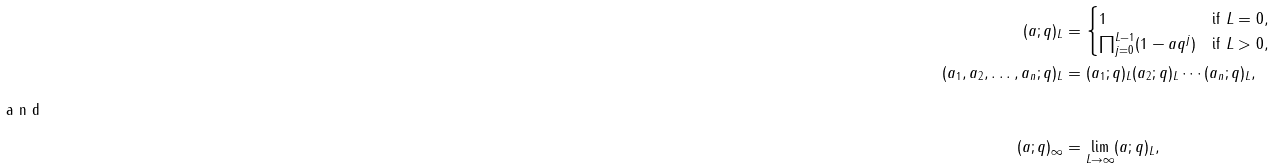<formula> <loc_0><loc_0><loc_500><loc_500>( a ; q ) _ { L } & = \begin{cases} 1 & \text {if } L = 0 , \\ \prod _ { j = 0 } ^ { L - 1 } ( 1 - a q ^ { j } ) & \text {if } L > 0 , \end{cases} \\ ( a _ { 1 } , a _ { 2 } , \dots , a _ { n } ; q ) _ { L } & = ( a _ { 1 } ; q ) _ { L } ( a _ { 2 } ; q ) _ { L } \cdots ( a _ { n } ; q ) _ { L } , \\ \intertext { a n d } ( a ; q ) _ { \infty } & = \lim _ { L \to \infty } ( a ; q ) _ { L } ,</formula> 